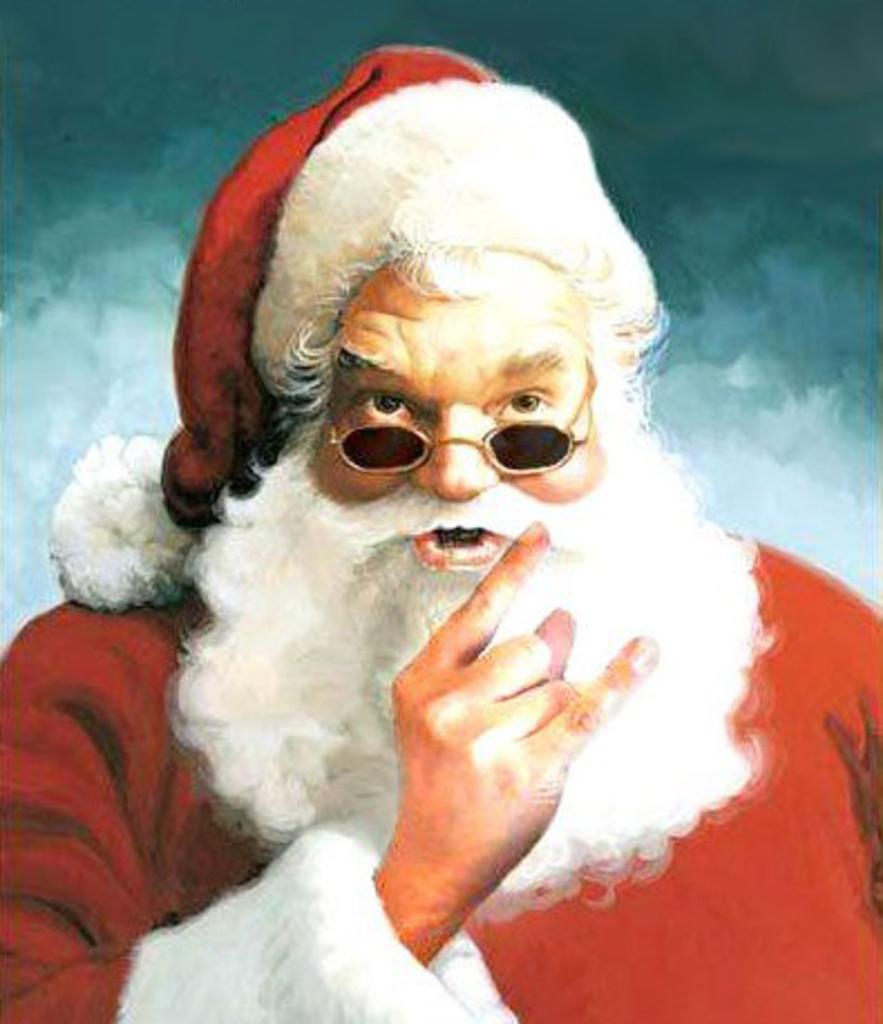What is present in the image? There is a person in the image. Can you describe the person's attire? The person is wearing a cap and spectacles. What type of quilt is being used to cover the person in the image? There is no quilt present in the image; the person is wearing a cap and spectacles. What is the air like in the image? The facts provided do not give any information about the air or weather conditions in the image. 